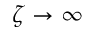Convert formula to latex. <formula><loc_0><loc_0><loc_500><loc_500>\zeta \rightarrow \infty</formula> 